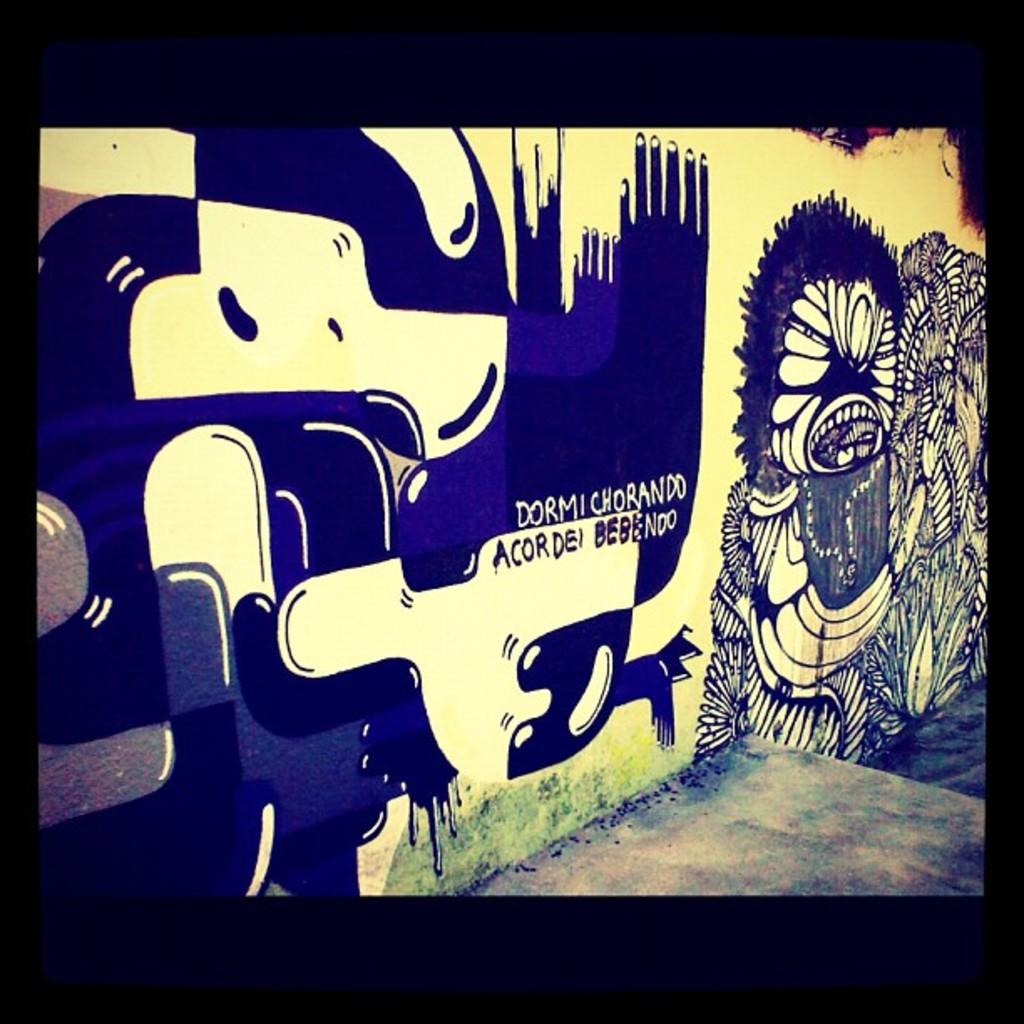What is on the wall in the image? There is a painting on the wall in the image. What can be found within the painting? The painting contains images and text. What surface is visible beneath the painting? There is a floor visible in the image. How many dimes can be seen on the floor in the image? There are no dimes visible on the floor in the image. Is there a bathtub present in the image? There is no bathtub present in the image. 